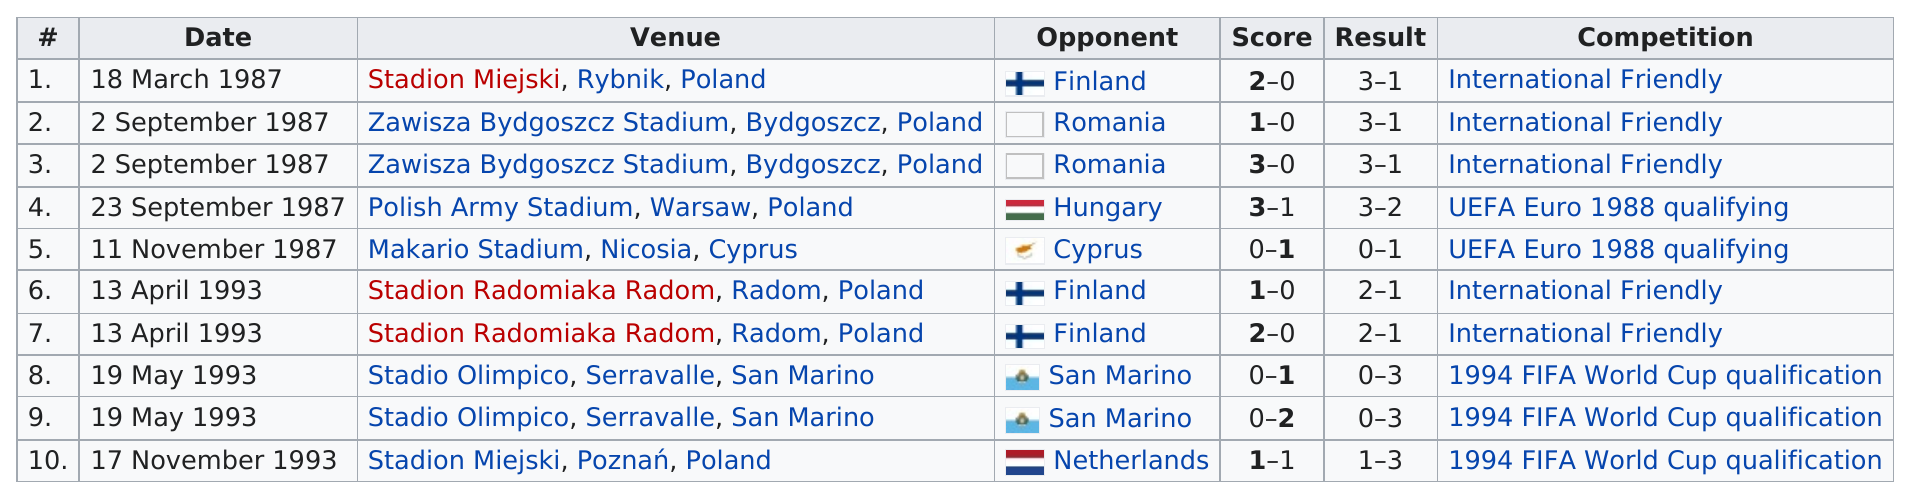Identify some key points in this picture. Finland was the opponent on three occasions. The game that occurred in Cyprus on November 11, 1987, was the only game of its kind. There were 7 competitions that were not for the FIFA World Cup. In 1987, the total amount of games played was 5. A total of 5 international friendly matches have taken place. 